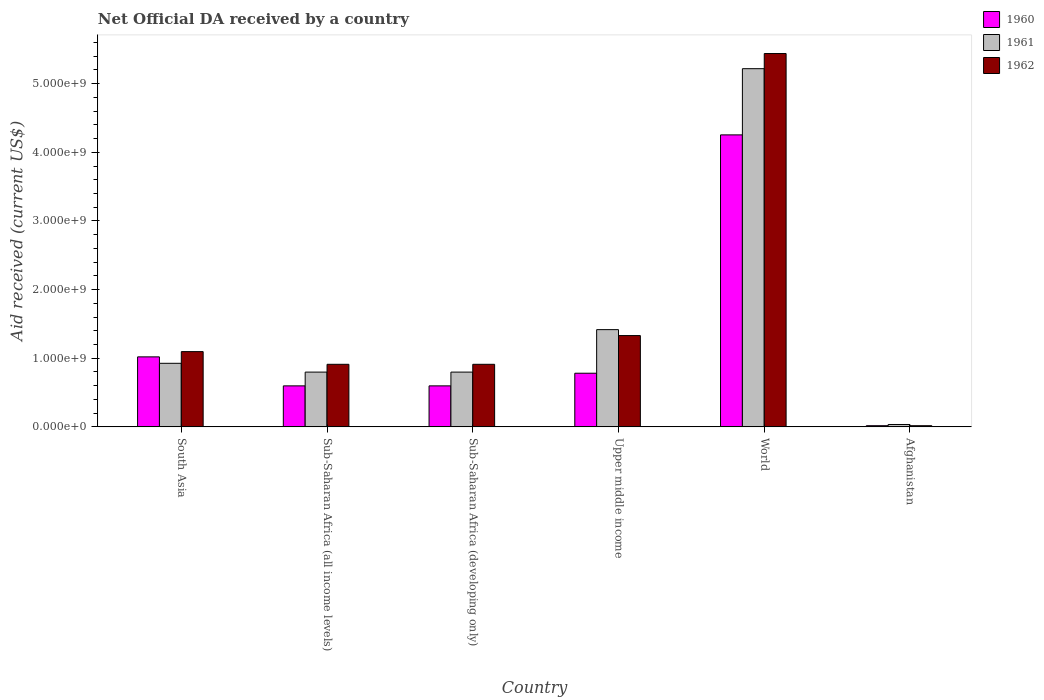How many different coloured bars are there?
Make the answer very short. 3. How many groups of bars are there?
Make the answer very short. 6. Are the number of bars on each tick of the X-axis equal?
Provide a succinct answer. Yes. What is the label of the 6th group of bars from the left?
Offer a very short reply. Afghanistan. In how many cases, is the number of bars for a given country not equal to the number of legend labels?
Make the answer very short. 0. What is the net official development assistance aid received in 1962 in World?
Provide a short and direct response. 5.44e+09. Across all countries, what is the maximum net official development assistance aid received in 1961?
Your response must be concise. 5.22e+09. Across all countries, what is the minimum net official development assistance aid received in 1960?
Keep it short and to the point. 1.72e+07. In which country was the net official development assistance aid received in 1962 maximum?
Keep it short and to the point. World. In which country was the net official development assistance aid received in 1961 minimum?
Your answer should be compact. Afghanistan. What is the total net official development assistance aid received in 1960 in the graph?
Your response must be concise. 7.27e+09. What is the difference between the net official development assistance aid received in 1960 in Sub-Saharan Africa (all income levels) and that in World?
Your answer should be very brief. -3.66e+09. What is the difference between the net official development assistance aid received in 1962 in Upper middle income and the net official development assistance aid received in 1961 in World?
Give a very brief answer. -3.89e+09. What is the average net official development assistance aid received in 1961 per country?
Your answer should be very brief. 1.53e+09. What is the difference between the net official development assistance aid received of/in 1961 and net official development assistance aid received of/in 1960 in Sub-Saharan Africa (developing only)?
Give a very brief answer. 2.01e+08. In how many countries, is the net official development assistance aid received in 1961 greater than 4200000000 US$?
Provide a succinct answer. 1. What is the ratio of the net official development assistance aid received in 1960 in Sub-Saharan Africa (all income levels) to that in Upper middle income?
Your response must be concise. 0.76. Is the difference between the net official development assistance aid received in 1961 in Sub-Saharan Africa (developing only) and Upper middle income greater than the difference between the net official development assistance aid received in 1960 in Sub-Saharan Africa (developing only) and Upper middle income?
Your response must be concise. No. What is the difference between the highest and the second highest net official development assistance aid received in 1961?
Your answer should be very brief. 4.29e+09. What is the difference between the highest and the lowest net official development assistance aid received in 1961?
Make the answer very short. 5.18e+09. In how many countries, is the net official development assistance aid received in 1960 greater than the average net official development assistance aid received in 1960 taken over all countries?
Your answer should be very brief. 1. What does the 2nd bar from the left in Sub-Saharan Africa (all income levels) represents?
Provide a succinct answer. 1961. Is it the case that in every country, the sum of the net official development assistance aid received in 1962 and net official development assistance aid received in 1960 is greater than the net official development assistance aid received in 1961?
Provide a short and direct response. No. Are all the bars in the graph horizontal?
Keep it short and to the point. No. Does the graph contain any zero values?
Make the answer very short. No. Where does the legend appear in the graph?
Offer a very short reply. Top right. How are the legend labels stacked?
Offer a very short reply. Vertical. What is the title of the graph?
Provide a short and direct response. Net Official DA received by a country. What is the label or title of the X-axis?
Provide a succinct answer. Country. What is the label or title of the Y-axis?
Provide a short and direct response. Aid received (current US$). What is the Aid received (current US$) of 1960 in South Asia?
Ensure brevity in your answer.  1.02e+09. What is the Aid received (current US$) in 1961 in South Asia?
Give a very brief answer. 9.26e+08. What is the Aid received (current US$) of 1962 in South Asia?
Your answer should be compact. 1.10e+09. What is the Aid received (current US$) in 1960 in Sub-Saharan Africa (all income levels)?
Give a very brief answer. 5.97e+08. What is the Aid received (current US$) in 1961 in Sub-Saharan Africa (all income levels)?
Offer a very short reply. 7.98e+08. What is the Aid received (current US$) in 1962 in Sub-Saharan Africa (all income levels)?
Offer a terse response. 9.12e+08. What is the Aid received (current US$) in 1960 in Sub-Saharan Africa (developing only)?
Provide a succinct answer. 5.97e+08. What is the Aid received (current US$) in 1961 in Sub-Saharan Africa (developing only)?
Give a very brief answer. 7.98e+08. What is the Aid received (current US$) of 1962 in Sub-Saharan Africa (developing only)?
Offer a very short reply. 9.12e+08. What is the Aid received (current US$) of 1960 in Upper middle income?
Your response must be concise. 7.82e+08. What is the Aid received (current US$) of 1961 in Upper middle income?
Your answer should be compact. 1.42e+09. What is the Aid received (current US$) in 1962 in Upper middle income?
Keep it short and to the point. 1.33e+09. What is the Aid received (current US$) in 1960 in World?
Ensure brevity in your answer.  4.25e+09. What is the Aid received (current US$) in 1961 in World?
Offer a very short reply. 5.22e+09. What is the Aid received (current US$) of 1962 in World?
Offer a very short reply. 5.44e+09. What is the Aid received (current US$) in 1960 in Afghanistan?
Keep it short and to the point. 1.72e+07. What is the Aid received (current US$) in 1961 in Afghanistan?
Provide a short and direct response. 3.47e+07. What is the Aid received (current US$) in 1962 in Afghanistan?
Offer a very short reply. 1.69e+07. Across all countries, what is the maximum Aid received (current US$) in 1960?
Provide a succinct answer. 4.25e+09. Across all countries, what is the maximum Aid received (current US$) of 1961?
Provide a short and direct response. 5.22e+09. Across all countries, what is the maximum Aid received (current US$) of 1962?
Make the answer very short. 5.44e+09. Across all countries, what is the minimum Aid received (current US$) in 1960?
Ensure brevity in your answer.  1.72e+07. Across all countries, what is the minimum Aid received (current US$) in 1961?
Ensure brevity in your answer.  3.47e+07. Across all countries, what is the minimum Aid received (current US$) of 1962?
Give a very brief answer. 1.69e+07. What is the total Aid received (current US$) in 1960 in the graph?
Make the answer very short. 7.27e+09. What is the total Aid received (current US$) in 1961 in the graph?
Provide a succinct answer. 9.19e+09. What is the total Aid received (current US$) in 1962 in the graph?
Your answer should be very brief. 9.71e+09. What is the difference between the Aid received (current US$) in 1960 in South Asia and that in Sub-Saharan Africa (all income levels)?
Provide a succinct answer. 4.23e+08. What is the difference between the Aid received (current US$) of 1961 in South Asia and that in Sub-Saharan Africa (all income levels)?
Make the answer very short. 1.28e+08. What is the difference between the Aid received (current US$) in 1962 in South Asia and that in Sub-Saharan Africa (all income levels)?
Your answer should be very brief. 1.85e+08. What is the difference between the Aid received (current US$) in 1960 in South Asia and that in Sub-Saharan Africa (developing only)?
Keep it short and to the point. 4.23e+08. What is the difference between the Aid received (current US$) of 1961 in South Asia and that in Sub-Saharan Africa (developing only)?
Keep it short and to the point. 1.28e+08. What is the difference between the Aid received (current US$) in 1962 in South Asia and that in Sub-Saharan Africa (developing only)?
Give a very brief answer. 1.85e+08. What is the difference between the Aid received (current US$) in 1960 in South Asia and that in Upper middle income?
Your answer should be very brief. 2.38e+08. What is the difference between the Aid received (current US$) in 1961 in South Asia and that in Upper middle income?
Offer a terse response. -4.91e+08. What is the difference between the Aid received (current US$) of 1962 in South Asia and that in Upper middle income?
Keep it short and to the point. -2.34e+08. What is the difference between the Aid received (current US$) of 1960 in South Asia and that in World?
Your answer should be compact. -3.23e+09. What is the difference between the Aid received (current US$) in 1961 in South Asia and that in World?
Offer a very short reply. -4.29e+09. What is the difference between the Aid received (current US$) in 1962 in South Asia and that in World?
Your response must be concise. -4.34e+09. What is the difference between the Aid received (current US$) in 1960 in South Asia and that in Afghanistan?
Make the answer very short. 1.00e+09. What is the difference between the Aid received (current US$) in 1961 in South Asia and that in Afghanistan?
Keep it short and to the point. 8.92e+08. What is the difference between the Aid received (current US$) in 1962 in South Asia and that in Afghanistan?
Make the answer very short. 1.08e+09. What is the difference between the Aid received (current US$) in 1961 in Sub-Saharan Africa (all income levels) and that in Sub-Saharan Africa (developing only)?
Offer a very short reply. 0. What is the difference between the Aid received (current US$) of 1962 in Sub-Saharan Africa (all income levels) and that in Sub-Saharan Africa (developing only)?
Your answer should be compact. 0. What is the difference between the Aid received (current US$) in 1960 in Sub-Saharan Africa (all income levels) and that in Upper middle income?
Ensure brevity in your answer.  -1.84e+08. What is the difference between the Aid received (current US$) in 1961 in Sub-Saharan Africa (all income levels) and that in Upper middle income?
Provide a succinct answer. -6.19e+08. What is the difference between the Aid received (current US$) in 1962 in Sub-Saharan Africa (all income levels) and that in Upper middle income?
Offer a terse response. -4.19e+08. What is the difference between the Aid received (current US$) of 1960 in Sub-Saharan Africa (all income levels) and that in World?
Ensure brevity in your answer.  -3.66e+09. What is the difference between the Aid received (current US$) in 1961 in Sub-Saharan Africa (all income levels) and that in World?
Offer a very short reply. -4.42e+09. What is the difference between the Aid received (current US$) of 1962 in Sub-Saharan Africa (all income levels) and that in World?
Ensure brevity in your answer.  -4.53e+09. What is the difference between the Aid received (current US$) in 1960 in Sub-Saharan Africa (all income levels) and that in Afghanistan?
Your response must be concise. 5.80e+08. What is the difference between the Aid received (current US$) in 1961 in Sub-Saharan Africa (all income levels) and that in Afghanistan?
Your response must be concise. 7.63e+08. What is the difference between the Aid received (current US$) in 1962 in Sub-Saharan Africa (all income levels) and that in Afghanistan?
Offer a very short reply. 8.95e+08. What is the difference between the Aid received (current US$) in 1960 in Sub-Saharan Africa (developing only) and that in Upper middle income?
Your answer should be compact. -1.84e+08. What is the difference between the Aid received (current US$) of 1961 in Sub-Saharan Africa (developing only) and that in Upper middle income?
Your response must be concise. -6.19e+08. What is the difference between the Aid received (current US$) in 1962 in Sub-Saharan Africa (developing only) and that in Upper middle income?
Ensure brevity in your answer.  -4.19e+08. What is the difference between the Aid received (current US$) of 1960 in Sub-Saharan Africa (developing only) and that in World?
Give a very brief answer. -3.66e+09. What is the difference between the Aid received (current US$) in 1961 in Sub-Saharan Africa (developing only) and that in World?
Give a very brief answer. -4.42e+09. What is the difference between the Aid received (current US$) of 1962 in Sub-Saharan Africa (developing only) and that in World?
Offer a terse response. -4.53e+09. What is the difference between the Aid received (current US$) in 1960 in Sub-Saharan Africa (developing only) and that in Afghanistan?
Provide a succinct answer. 5.80e+08. What is the difference between the Aid received (current US$) of 1961 in Sub-Saharan Africa (developing only) and that in Afghanistan?
Ensure brevity in your answer.  7.63e+08. What is the difference between the Aid received (current US$) of 1962 in Sub-Saharan Africa (developing only) and that in Afghanistan?
Provide a succinct answer. 8.95e+08. What is the difference between the Aid received (current US$) in 1960 in Upper middle income and that in World?
Keep it short and to the point. -3.47e+09. What is the difference between the Aid received (current US$) of 1961 in Upper middle income and that in World?
Keep it short and to the point. -3.80e+09. What is the difference between the Aid received (current US$) of 1962 in Upper middle income and that in World?
Offer a very short reply. -4.11e+09. What is the difference between the Aid received (current US$) in 1960 in Upper middle income and that in Afghanistan?
Your answer should be compact. 7.64e+08. What is the difference between the Aid received (current US$) in 1961 in Upper middle income and that in Afghanistan?
Offer a very short reply. 1.38e+09. What is the difference between the Aid received (current US$) of 1962 in Upper middle income and that in Afghanistan?
Your response must be concise. 1.31e+09. What is the difference between the Aid received (current US$) in 1960 in World and that in Afghanistan?
Make the answer very short. 4.24e+09. What is the difference between the Aid received (current US$) of 1961 in World and that in Afghanistan?
Ensure brevity in your answer.  5.18e+09. What is the difference between the Aid received (current US$) of 1962 in World and that in Afghanistan?
Your response must be concise. 5.42e+09. What is the difference between the Aid received (current US$) in 1960 in South Asia and the Aid received (current US$) in 1961 in Sub-Saharan Africa (all income levels)?
Keep it short and to the point. 2.22e+08. What is the difference between the Aid received (current US$) in 1960 in South Asia and the Aid received (current US$) in 1962 in Sub-Saharan Africa (all income levels)?
Your answer should be very brief. 1.08e+08. What is the difference between the Aid received (current US$) in 1961 in South Asia and the Aid received (current US$) in 1962 in Sub-Saharan Africa (all income levels)?
Keep it short and to the point. 1.45e+07. What is the difference between the Aid received (current US$) in 1960 in South Asia and the Aid received (current US$) in 1961 in Sub-Saharan Africa (developing only)?
Ensure brevity in your answer.  2.22e+08. What is the difference between the Aid received (current US$) of 1960 in South Asia and the Aid received (current US$) of 1962 in Sub-Saharan Africa (developing only)?
Your response must be concise. 1.08e+08. What is the difference between the Aid received (current US$) of 1961 in South Asia and the Aid received (current US$) of 1962 in Sub-Saharan Africa (developing only)?
Your answer should be very brief. 1.45e+07. What is the difference between the Aid received (current US$) of 1960 in South Asia and the Aid received (current US$) of 1961 in Upper middle income?
Offer a very short reply. -3.97e+08. What is the difference between the Aid received (current US$) of 1960 in South Asia and the Aid received (current US$) of 1962 in Upper middle income?
Your answer should be compact. -3.10e+08. What is the difference between the Aid received (current US$) in 1961 in South Asia and the Aid received (current US$) in 1962 in Upper middle income?
Provide a short and direct response. -4.04e+08. What is the difference between the Aid received (current US$) in 1960 in South Asia and the Aid received (current US$) in 1961 in World?
Ensure brevity in your answer.  -4.20e+09. What is the difference between the Aid received (current US$) in 1960 in South Asia and the Aid received (current US$) in 1962 in World?
Offer a very short reply. -4.42e+09. What is the difference between the Aid received (current US$) in 1961 in South Asia and the Aid received (current US$) in 1962 in World?
Your answer should be compact. -4.51e+09. What is the difference between the Aid received (current US$) in 1960 in South Asia and the Aid received (current US$) in 1961 in Afghanistan?
Offer a very short reply. 9.85e+08. What is the difference between the Aid received (current US$) of 1960 in South Asia and the Aid received (current US$) of 1962 in Afghanistan?
Provide a succinct answer. 1.00e+09. What is the difference between the Aid received (current US$) of 1961 in South Asia and the Aid received (current US$) of 1962 in Afghanistan?
Offer a terse response. 9.09e+08. What is the difference between the Aid received (current US$) in 1960 in Sub-Saharan Africa (all income levels) and the Aid received (current US$) in 1961 in Sub-Saharan Africa (developing only)?
Provide a short and direct response. -2.01e+08. What is the difference between the Aid received (current US$) in 1960 in Sub-Saharan Africa (all income levels) and the Aid received (current US$) in 1962 in Sub-Saharan Africa (developing only)?
Your answer should be compact. -3.14e+08. What is the difference between the Aid received (current US$) of 1961 in Sub-Saharan Africa (all income levels) and the Aid received (current US$) of 1962 in Sub-Saharan Africa (developing only)?
Offer a terse response. -1.14e+08. What is the difference between the Aid received (current US$) in 1960 in Sub-Saharan Africa (all income levels) and the Aid received (current US$) in 1961 in Upper middle income?
Your response must be concise. -8.19e+08. What is the difference between the Aid received (current US$) of 1960 in Sub-Saharan Africa (all income levels) and the Aid received (current US$) of 1962 in Upper middle income?
Offer a terse response. -7.33e+08. What is the difference between the Aid received (current US$) of 1961 in Sub-Saharan Africa (all income levels) and the Aid received (current US$) of 1962 in Upper middle income?
Give a very brief answer. -5.32e+08. What is the difference between the Aid received (current US$) in 1960 in Sub-Saharan Africa (all income levels) and the Aid received (current US$) in 1961 in World?
Your response must be concise. -4.62e+09. What is the difference between the Aid received (current US$) in 1960 in Sub-Saharan Africa (all income levels) and the Aid received (current US$) in 1962 in World?
Ensure brevity in your answer.  -4.84e+09. What is the difference between the Aid received (current US$) of 1961 in Sub-Saharan Africa (all income levels) and the Aid received (current US$) of 1962 in World?
Ensure brevity in your answer.  -4.64e+09. What is the difference between the Aid received (current US$) of 1960 in Sub-Saharan Africa (all income levels) and the Aid received (current US$) of 1961 in Afghanistan?
Your response must be concise. 5.63e+08. What is the difference between the Aid received (current US$) in 1960 in Sub-Saharan Africa (all income levels) and the Aid received (current US$) in 1962 in Afghanistan?
Offer a very short reply. 5.80e+08. What is the difference between the Aid received (current US$) of 1961 in Sub-Saharan Africa (all income levels) and the Aid received (current US$) of 1962 in Afghanistan?
Provide a succinct answer. 7.81e+08. What is the difference between the Aid received (current US$) in 1960 in Sub-Saharan Africa (developing only) and the Aid received (current US$) in 1961 in Upper middle income?
Your response must be concise. -8.19e+08. What is the difference between the Aid received (current US$) in 1960 in Sub-Saharan Africa (developing only) and the Aid received (current US$) in 1962 in Upper middle income?
Offer a very short reply. -7.33e+08. What is the difference between the Aid received (current US$) in 1961 in Sub-Saharan Africa (developing only) and the Aid received (current US$) in 1962 in Upper middle income?
Make the answer very short. -5.32e+08. What is the difference between the Aid received (current US$) in 1960 in Sub-Saharan Africa (developing only) and the Aid received (current US$) in 1961 in World?
Ensure brevity in your answer.  -4.62e+09. What is the difference between the Aid received (current US$) of 1960 in Sub-Saharan Africa (developing only) and the Aid received (current US$) of 1962 in World?
Your answer should be very brief. -4.84e+09. What is the difference between the Aid received (current US$) in 1961 in Sub-Saharan Africa (developing only) and the Aid received (current US$) in 1962 in World?
Your answer should be very brief. -4.64e+09. What is the difference between the Aid received (current US$) in 1960 in Sub-Saharan Africa (developing only) and the Aid received (current US$) in 1961 in Afghanistan?
Ensure brevity in your answer.  5.63e+08. What is the difference between the Aid received (current US$) in 1960 in Sub-Saharan Africa (developing only) and the Aid received (current US$) in 1962 in Afghanistan?
Offer a terse response. 5.80e+08. What is the difference between the Aid received (current US$) of 1961 in Sub-Saharan Africa (developing only) and the Aid received (current US$) of 1962 in Afghanistan?
Provide a succinct answer. 7.81e+08. What is the difference between the Aid received (current US$) in 1960 in Upper middle income and the Aid received (current US$) in 1961 in World?
Keep it short and to the point. -4.44e+09. What is the difference between the Aid received (current US$) of 1960 in Upper middle income and the Aid received (current US$) of 1962 in World?
Provide a succinct answer. -4.66e+09. What is the difference between the Aid received (current US$) in 1961 in Upper middle income and the Aid received (current US$) in 1962 in World?
Your answer should be very brief. -4.02e+09. What is the difference between the Aid received (current US$) of 1960 in Upper middle income and the Aid received (current US$) of 1961 in Afghanistan?
Your response must be concise. 7.47e+08. What is the difference between the Aid received (current US$) in 1960 in Upper middle income and the Aid received (current US$) in 1962 in Afghanistan?
Make the answer very short. 7.65e+08. What is the difference between the Aid received (current US$) in 1961 in Upper middle income and the Aid received (current US$) in 1962 in Afghanistan?
Your answer should be compact. 1.40e+09. What is the difference between the Aid received (current US$) of 1960 in World and the Aid received (current US$) of 1961 in Afghanistan?
Provide a short and direct response. 4.22e+09. What is the difference between the Aid received (current US$) in 1960 in World and the Aid received (current US$) in 1962 in Afghanistan?
Provide a succinct answer. 4.24e+09. What is the difference between the Aid received (current US$) of 1961 in World and the Aid received (current US$) of 1962 in Afghanistan?
Keep it short and to the point. 5.20e+09. What is the average Aid received (current US$) of 1960 per country?
Your response must be concise. 1.21e+09. What is the average Aid received (current US$) in 1961 per country?
Give a very brief answer. 1.53e+09. What is the average Aid received (current US$) of 1962 per country?
Offer a terse response. 1.62e+09. What is the difference between the Aid received (current US$) of 1960 and Aid received (current US$) of 1961 in South Asia?
Give a very brief answer. 9.39e+07. What is the difference between the Aid received (current US$) of 1960 and Aid received (current US$) of 1962 in South Asia?
Keep it short and to the point. -7.65e+07. What is the difference between the Aid received (current US$) of 1961 and Aid received (current US$) of 1962 in South Asia?
Ensure brevity in your answer.  -1.70e+08. What is the difference between the Aid received (current US$) in 1960 and Aid received (current US$) in 1961 in Sub-Saharan Africa (all income levels)?
Your response must be concise. -2.01e+08. What is the difference between the Aid received (current US$) of 1960 and Aid received (current US$) of 1962 in Sub-Saharan Africa (all income levels)?
Provide a succinct answer. -3.14e+08. What is the difference between the Aid received (current US$) of 1961 and Aid received (current US$) of 1962 in Sub-Saharan Africa (all income levels)?
Give a very brief answer. -1.14e+08. What is the difference between the Aid received (current US$) of 1960 and Aid received (current US$) of 1961 in Sub-Saharan Africa (developing only)?
Keep it short and to the point. -2.01e+08. What is the difference between the Aid received (current US$) of 1960 and Aid received (current US$) of 1962 in Sub-Saharan Africa (developing only)?
Ensure brevity in your answer.  -3.14e+08. What is the difference between the Aid received (current US$) in 1961 and Aid received (current US$) in 1962 in Sub-Saharan Africa (developing only)?
Provide a short and direct response. -1.14e+08. What is the difference between the Aid received (current US$) of 1960 and Aid received (current US$) of 1961 in Upper middle income?
Your response must be concise. -6.35e+08. What is the difference between the Aid received (current US$) in 1960 and Aid received (current US$) in 1962 in Upper middle income?
Make the answer very short. -5.49e+08. What is the difference between the Aid received (current US$) of 1961 and Aid received (current US$) of 1962 in Upper middle income?
Your answer should be compact. 8.65e+07. What is the difference between the Aid received (current US$) of 1960 and Aid received (current US$) of 1961 in World?
Your answer should be compact. -9.65e+08. What is the difference between the Aid received (current US$) of 1960 and Aid received (current US$) of 1962 in World?
Your answer should be very brief. -1.19e+09. What is the difference between the Aid received (current US$) of 1961 and Aid received (current US$) of 1962 in World?
Your response must be concise. -2.21e+08. What is the difference between the Aid received (current US$) of 1960 and Aid received (current US$) of 1961 in Afghanistan?
Keep it short and to the point. -1.75e+07. What is the difference between the Aid received (current US$) in 1960 and Aid received (current US$) in 1962 in Afghanistan?
Your answer should be compact. 2.50e+05. What is the difference between the Aid received (current US$) of 1961 and Aid received (current US$) of 1962 in Afghanistan?
Your answer should be very brief. 1.77e+07. What is the ratio of the Aid received (current US$) in 1960 in South Asia to that in Sub-Saharan Africa (all income levels)?
Ensure brevity in your answer.  1.71. What is the ratio of the Aid received (current US$) in 1961 in South Asia to that in Sub-Saharan Africa (all income levels)?
Your response must be concise. 1.16. What is the ratio of the Aid received (current US$) of 1962 in South Asia to that in Sub-Saharan Africa (all income levels)?
Give a very brief answer. 1.2. What is the ratio of the Aid received (current US$) of 1960 in South Asia to that in Sub-Saharan Africa (developing only)?
Provide a short and direct response. 1.71. What is the ratio of the Aid received (current US$) in 1961 in South Asia to that in Sub-Saharan Africa (developing only)?
Keep it short and to the point. 1.16. What is the ratio of the Aid received (current US$) of 1962 in South Asia to that in Sub-Saharan Africa (developing only)?
Provide a succinct answer. 1.2. What is the ratio of the Aid received (current US$) of 1960 in South Asia to that in Upper middle income?
Keep it short and to the point. 1.31. What is the ratio of the Aid received (current US$) of 1961 in South Asia to that in Upper middle income?
Give a very brief answer. 0.65. What is the ratio of the Aid received (current US$) of 1962 in South Asia to that in Upper middle income?
Make the answer very short. 0.82. What is the ratio of the Aid received (current US$) of 1960 in South Asia to that in World?
Keep it short and to the point. 0.24. What is the ratio of the Aid received (current US$) of 1961 in South Asia to that in World?
Your answer should be compact. 0.18. What is the ratio of the Aid received (current US$) of 1962 in South Asia to that in World?
Your response must be concise. 0.2. What is the ratio of the Aid received (current US$) in 1960 in South Asia to that in Afghanistan?
Make the answer very short. 59.38. What is the ratio of the Aid received (current US$) of 1961 in South Asia to that in Afghanistan?
Your answer should be very brief. 26.72. What is the ratio of the Aid received (current US$) in 1962 in South Asia to that in Afghanistan?
Your answer should be compact. 64.77. What is the ratio of the Aid received (current US$) in 1960 in Sub-Saharan Africa (all income levels) to that in Sub-Saharan Africa (developing only)?
Offer a terse response. 1. What is the ratio of the Aid received (current US$) in 1961 in Sub-Saharan Africa (all income levels) to that in Sub-Saharan Africa (developing only)?
Your answer should be very brief. 1. What is the ratio of the Aid received (current US$) in 1962 in Sub-Saharan Africa (all income levels) to that in Sub-Saharan Africa (developing only)?
Your answer should be compact. 1. What is the ratio of the Aid received (current US$) in 1960 in Sub-Saharan Africa (all income levels) to that in Upper middle income?
Your answer should be compact. 0.76. What is the ratio of the Aid received (current US$) of 1961 in Sub-Saharan Africa (all income levels) to that in Upper middle income?
Your answer should be very brief. 0.56. What is the ratio of the Aid received (current US$) of 1962 in Sub-Saharan Africa (all income levels) to that in Upper middle income?
Provide a succinct answer. 0.69. What is the ratio of the Aid received (current US$) in 1960 in Sub-Saharan Africa (all income levels) to that in World?
Your answer should be compact. 0.14. What is the ratio of the Aid received (current US$) of 1961 in Sub-Saharan Africa (all income levels) to that in World?
Offer a very short reply. 0.15. What is the ratio of the Aid received (current US$) of 1962 in Sub-Saharan Africa (all income levels) to that in World?
Your answer should be compact. 0.17. What is the ratio of the Aid received (current US$) of 1960 in Sub-Saharan Africa (all income levels) to that in Afghanistan?
Provide a succinct answer. 34.77. What is the ratio of the Aid received (current US$) of 1961 in Sub-Saharan Africa (all income levels) to that in Afghanistan?
Provide a short and direct response. 23.02. What is the ratio of the Aid received (current US$) of 1962 in Sub-Saharan Africa (all income levels) to that in Afghanistan?
Your response must be concise. 53.85. What is the ratio of the Aid received (current US$) of 1960 in Sub-Saharan Africa (developing only) to that in Upper middle income?
Provide a short and direct response. 0.76. What is the ratio of the Aid received (current US$) of 1961 in Sub-Saharan Africa (developing only) to that in Upper middle income?
Provide a succinct answer. 0.56. What is the ratio of the Aid received (current US$) of 1962 in Sub-Saharan Africa (developing only) to that in Upper middle income?
Provide a short and direct response. 0.69. What is the ratio of the Aid received (current US$) in 1960 in Sub-Saharan Africa (developing only) to that in World?
Your answer should be very brief. 0.14. What is the ratio of the Aid received (current US$) in 1961 in Sub-Saharan Africa (developing only) to that in World?
Ensure brevity in your answer.  0.15. What is the ratio of the Aid received (current US$) of 1962 in Sub-Saharan Africa (developing only) to that in World?
Your answer should be compact. 0.17. What is the ratio of the Aid received (current US$) in 1960 in Sub-Saharan Africa (developing only) to that in Afghanistan?
Provide a short and direct response. 34.77. What is the ratio of the Aid received (current US$) in 1961 in Sub-Saharan Africa (developing only) to that in Afghanistan?
Make the answer very short. 23.02. What is the ratio of the Aid received (current US$) of 1962 in Sub-Saharan Africa (developing only) to that in Afghanistan?
Your response must be concise. 53.85. What is the ratio of the Aid received (current US$) in 1960 in Upper middle income to that in World?
Make the answer very short. 0.18. What is the ratio of the Aid received (current US$) of 1961 in Upper middle income to that in World?
Provide a succinct answer. 0.27. What is the ratio of the Aid received (current US$) in 1962 in Upper middle income to that in World?
Your answer should be very brief. 0.24. What is the ratio of the Aid received (current US$) in 1960 in Upper middle income to that in Afghanistan?
Provide a succinct answer. 45.5. What is the ratio of the Aid received (current US$) in 1961 in Upper middle income to that in Afghanistan?
Offer a terse response. 40.86. What is the ratio of the Aid received (current US$) in 1962 in Upper middle income to that in Afghanistan?
Make the answer very short. 78.58. What is the ratio of the Aid received (current US$) in 1960 in World to that in Afghanistan?
Your answer should be compact. 247.64. What is the ratio of the Aid received (current US$) in 1961 in World to that in Afghanistan?
Provide a short and direct response. 150.53. What is the ratio of the Aid received (current US$) of 1962 in World to that in Afghanistan?
Ensure brevity in your answer.  321.3. What is the difference between the highest and the second highest Aid received (current US$) in 1960?
Provide a succinct answer. 3.23e+09. What is the difference between the highest and the second highest Aid received (current US$) of 1961?
Your answer should be very brief. 3.80e+09. What is the difference between the highest and the second highest Aid received (current US$) of 1962?
Your response must be concise. 4.11e+09. What is the difference between the highest and the lowest Aid received (current US$) in 1960?
Offer a very short reply. 4.24e+09. What is the difference between the highest and the lowest Aid received (current US$) of 1961?
Ensure brevity in your answer.  5.18e+09. What is the difference between the highest and the lowest Aid received (current US$) in 1962?
Make the answer very short. 5.42e+09. 